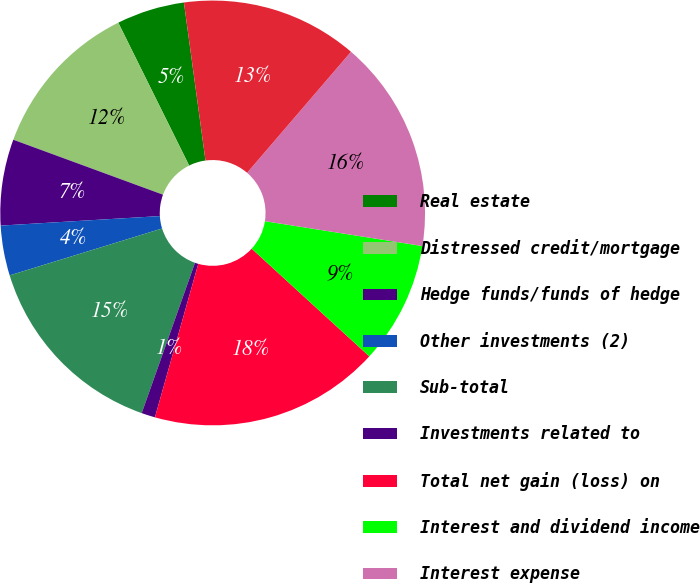Convert chart. <chart><loc_0><loc_0><loc_500><loc_500><pie_chart><fcel>Real estate<fcel>Distressed credit/mortgage<fcel>Hedge funds/funds of hedge<fcel>Other investments (2)<fcel>Sub-total<fcel>Investments related to<fcel>Total net gain (loss) on<fcel>Interest and dividend income<fcel>Interest expense<fcel>Net interest expense<nl><fcel>5.17%<fcel>12.07%<fcel>6.55%<fcel>3.8%<fcel>14.83%<fcel>1.04%<fcel>17.58%<fcel>9.31%<fcel>16.2%<fcel>13.45%<nl></chart> 